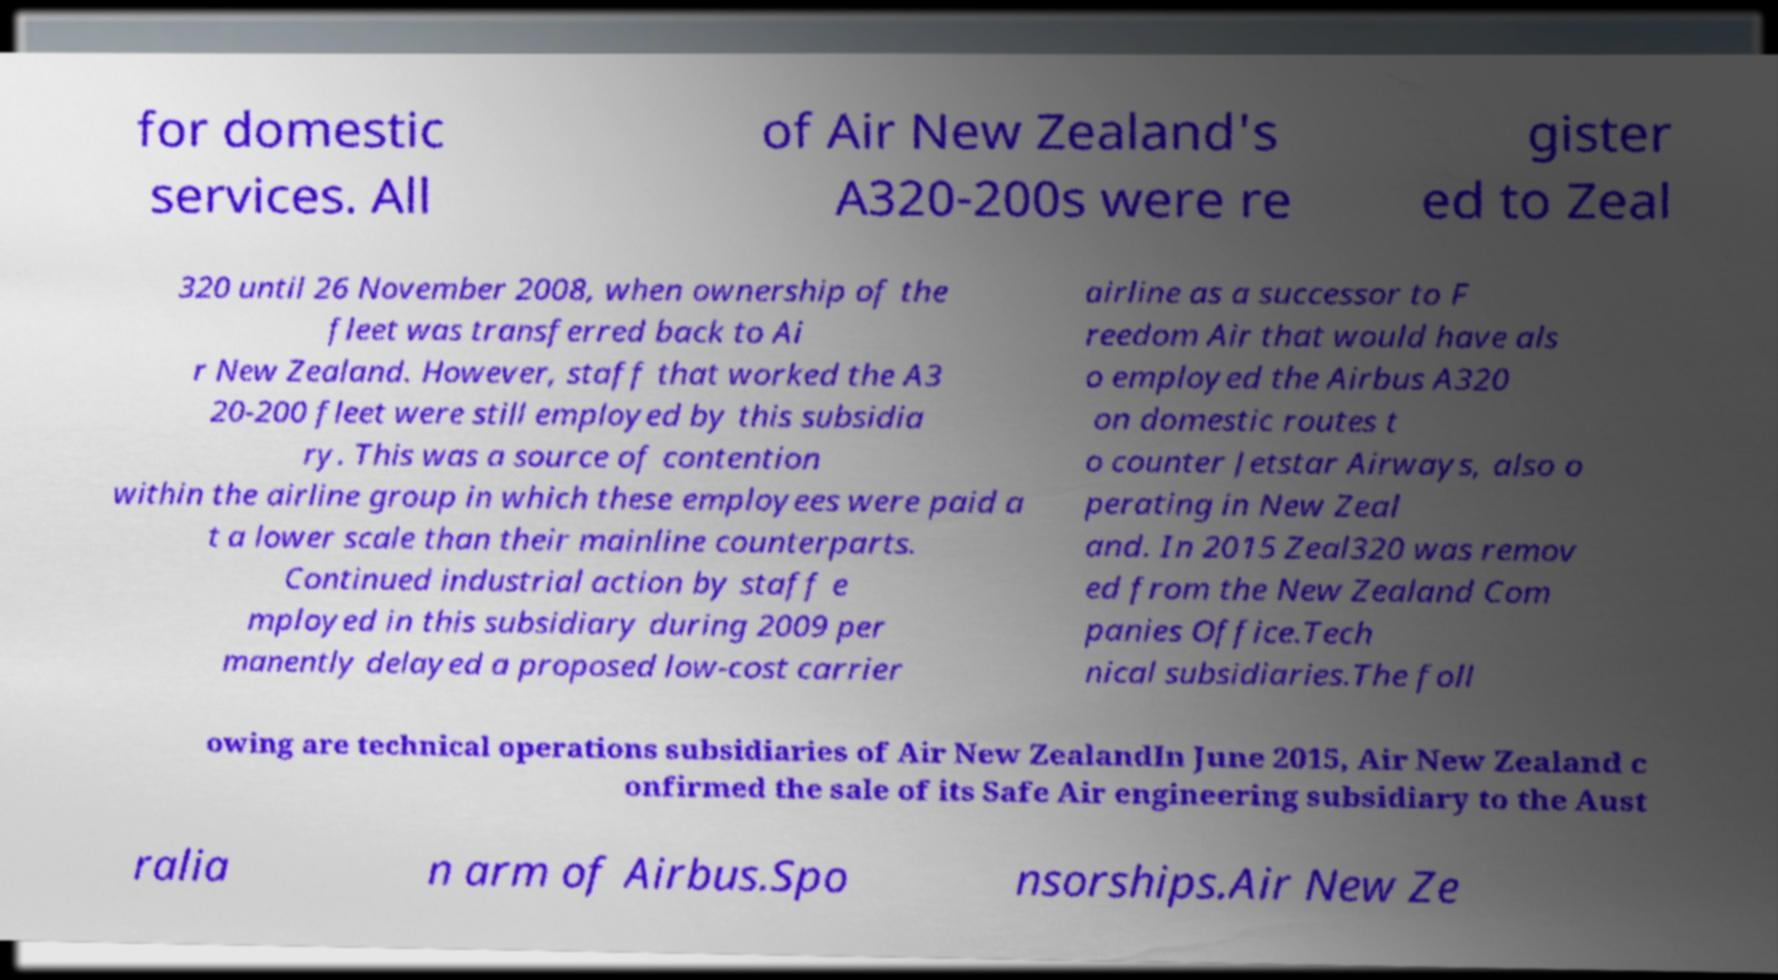I need the written content from this picture converted into text. Can you do that? for domestic services. All of Air New Zealand's A320-200s were re gister ed to Zeal 320 until 26 November 2008, when ownership of the fleet was transferred back to Ai r New Zealand. However, staff that worked the A3 20-200 fleet were still employed by this subsidia ry. This was a source of contention within the airline group in which these employees were paid a t a lower scale than their mainline counterparts. Continued industrial action by staff e mployed in this subsidiary during 2009 per manently delayed a proposed low-cost carrier airline as a successor to F reedom Air that would have als o employed the Airbus A320 on domestic routes t o counter Jetstar Airways, also o perating in New Zeal and. In 2015 Zeal320 was remov ed from the New Zealand Com panies Office.Tech nical subsidiaries.The foll owing are technical operations subsidiaries of Air New ZealandIn June 2015, Air New Zealand c onfirmed the sale of its Safe Air engineering subsidiary to the Aust ralia n arm of Airbus.Spo nsorships.Air New Ze 